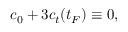Convert formula to latex. <formula><loc_0><loc_0><loc_500><loc_500>c _ { 0 } + 3 c _ { t } ( t _ { F } ) \equiv 0 ,</formula> 